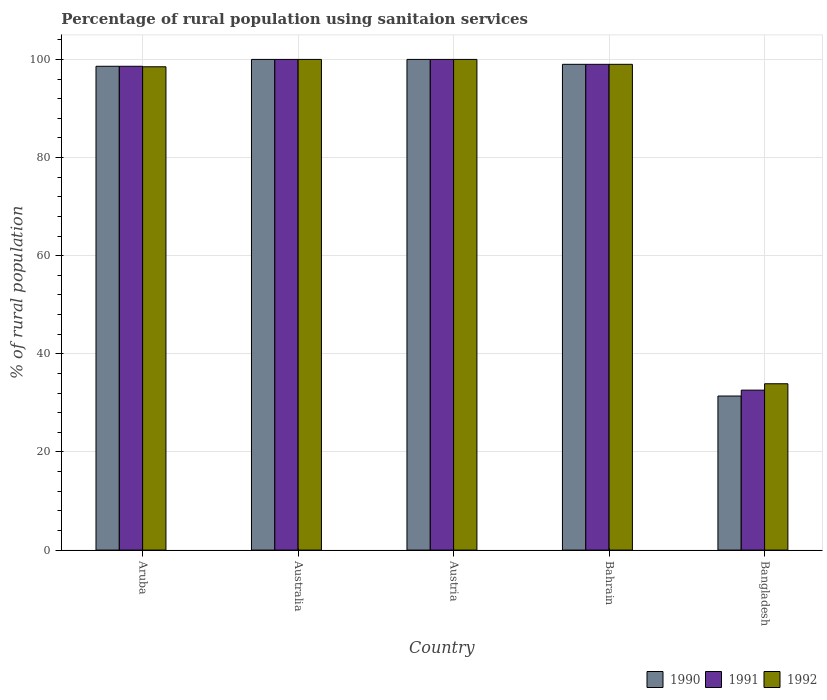How many different coloured bars are there?
Offer a terse response. 3. How many groups of bars are there?
Keep it short and to the point. 5. How many bars are there on the 5th tick from the left?
Your answer should be compact. 3. How many bars are there on the 1st tick from the right?
Keep it short and to the point. 3. What is the label of the 1st group of bars from the left?
Keep it short and to the point. Aruba. In how many cases, is the number of bars for a given country not equal to the number of legend labels?
Provide a succinct answer. 0. Across all countries, what is the minimum percentage of rural population using sanitaion services in 1991?
Provide a short and direct response. 32.6. In which country was the percentage of rural population using sanitaion services in 1990 maximum?
Your response must be concise. Australia. In which country was the percentage of rural population using sanitaion services in 1992 minimum?
Give a very brief answer. Bangladesh. What is the total percentage of rural population using sanitaion services in 1992 in the graph?
Ensure brevity in your answer.  431.4. What is the difference between the percentage of rural population using sanitaion services in 1991 in Australia and that in Bahrain?
Your response must be concise. 1. What is the average percentage of rural population using sanitaion services in 1991 per country?
Make the answer very short. 86.04. In how many countries, is the percentage of rural population using sanitaion services in 1992 greater than 88 %?
Ensure brevity in your answer.  4. What is the ratio of the percentage of rural population using sanitaion services in 1991 in Aruba to that in Bangladesh?
Offer a terse response. 3.02. Is the difference between the percentage of rural population using sanitaion services in 1992 in Australia and Bahrain greater than the difference between the percentage of rural population using sanitaion services in 1990 in Australia and Bahrain?
Offer a very short reply. No. What is the difference between the highest and the lowest percentage of rural population using sanitaion services in 1992?
Offer a very short reply. 66.1. In how many countries, is the percentage of rural population using sanitaion services in 1990 greater than the average percentage of rural population using sanitaion services in 1990 taken over all countries?
Make the answer very short. 4. Is the sum of the percentage of rural population using sanitaion services in 1991 in Aruba and Australia greater than the maximum percentage of rural population using sanitaion services in 1992 across all countries?
Offer a terse response. Yes. What does the 1st bar from the left in Australia represents?
Your response must be concise. 1990. Are all the bars in the graph horizontal?
Make the answer very short. No. What is the difference between two consecutive major ticks on the Y-axis?
Your answer should be very brief. 20. Does the graph contain grids?
Make the answer very short. Yes. How many legend labels are there?
Give a very brief answer. 3. How are the legend labels stacked?
Your answer should be very brief. Horizontal. What is the title of the graph?
Make the answer very short. Percentage of rural population using sanitaion services. Does "2007" appear as one of the legend labels in the graph?
Your answer should be very brief. No. What is the label or title of the Y-axis?
Ensure brevity in your answer.  % of rural population. What is the % of rural population of 1990 in Aruba?
Your answer should be very brief. 98.6. What is the % of rural population of 1991 in Aruba?
Offer a very short reply. 98.6. What is the % of rural population of 1992 in Aruba?
Provide a succinct answer. 98.5. What is the % of rural population in 1992 in Australia?
Your answer should be very brief. 100. What is the % of rural population of 1992 in Austria?
Your answer should be very brief. 100. What is the % of rural population of 1992 in Bahrain?
Your answer should be compact. 99. What is the % of rural population in 1990 in Bangladesh?
Give a very brief answer. 31.4. What is the % of rural population of 1991 in Bangladesh?
Your response must be concise. 32.6. What is the % of rural population of 1992 in Bangladesh?
Ensure brevity in your answer.  33.9. Across all countries, what is the maximum % of rural population in 1991?
Give a very brief answer. 100. Across all countries, what is the minimum % of rural population in 1990?
Give a very brief answer. 31.4. Across all countries, what is the minimum % of rural population in 1991?
Provide a succinct answer. 32.6. Across all countries, what is the minimum % of rural population of 1992?
Provide a short and direct response. 33.9. What is the total % of rural population of 1990 in the graph?
Your answer should be compact. 429. What is the total % of rural population of 1991 in the graph?
Offer a very short reply. 430.2. What is the total % of rural population in 1992 in the graph?
Provide a succinct answer. 431.4. What is the difference between the % of rural population of 1991 in Aruba and that in Australia?
Your response must be concise. -1.4. What is the difference between the % of rural population in 1992 in Aruba and that in Australia?
Offer a terse response. -1.5. What is the difference between the % of rural population in 1990 in Aruba and that in Austria?
Give a very brief answer. -1.4. What is the difference between the % of rural population of 1990 in Aruba and that in Bahrain?
Make the answer very short. -0.4. What is the difference between the % of rural population in 1991 in Aruba and that in Bahrain?
Offer a terse response. -0.4. What is the difference between the % of rural population in 1990 in Aruba and that in Bangladesh?
Offer a terse response. 67.2. What is the difference between the % of rural population in 1992 in Aruba and that in Bangladesh?
Ensure brevity in your answer.  64.6. What is the difference between the % of rural population in 1990 in Australia and that in Austria?
Your answer should be compact. 0. What is the difference between the % of rural population of 1992 in Australia and that in Austria?
Your answer should be very brief. 0. What is the difference between the % of rural population in 1991 in Australia and that in Bahrain?
Ensure brevity in your answer.  1. What is the difference between the % of rural population in 1992 in Australia and that in Bahrain?
Make the answer very short. 1. What is the difference between the % of rural population of 1990 in Australia and that in Bangladesh?
Make the answer very short. 68.6. What is the difference between the % of rural population of 1991 in Australia and that in Bangladesh?
Provide a short and direct response. 67.4. What is the difference between the % of rural population in 1992 in Australia and that in Bangladesh?
Make the answer very short. 66.1. What is the difference between the % of rural population in 1992 in Austria and that in Bahrain?
Provide a succinct answer. 1. What is the difference between the % of rural population in 1990 in Austria and that in Bangladesh?
Your answer should be compact. 68.6. What is the difference between the % of rural population in 1991 in Austria and that in Bangladesh?
Make the answer very short. 67.4. What is the difference between the % of rural population in 1992 in Austria and that in Bangladesh?
Your response must be concise. 66.1. What is the difference between the % of rural population of 1990 in Bahrain and that in Bangladesh?
Your response must be concise. 67.6. What is the difference between the % of rural population in 1991 in Bahrain and that in Bangladesh?
Provide a succinct answer. 66.4. What is the difference between the % of rural population of 1992 in Bahrain and that in Bangladesh?
Your response must be concise. 65.1. What is the difference between the % of rural population in 1990 in Aruba and the % of rural population in 1992 in Australia?
Your answer should be very brief. -1.4. What is the difference between the % of rural population of 1990 in Aruba and the % of rural population of 1991 in Austria?
Your answer should be very brief. -1.4. What is the difference between the % of rural population of 1990 in Aruba and the % of rural population of 1992 in Austria?
Offer a terse response. -1.4. What is the difference between the % of rural population of 1990 in Aruba and the % of rural population of 1992 in Bahrain?
Keep it short and to the point. -0.4. What is the difference between the % of rural population of 1990 in Aruba and the % of rural population of 1992 in Bangladesh?
Offer a very short reply. 64.7. What is the difference between the % of rural population of 1991 in Aruba and the % of rural population of 1992 in Bangladesh?
Ensure brevity in your answer.  64.7. What is the difference between the % of rural population in 1990 in Australia and the % of rural population in 1992 in Bahrain?
Your answer should be compact. 1. What is the difference between the % of rural population in 1990 in Australia and the % of rural population in 1991 in Bangladesh?
Your answer should be very brief. 67.4. What is the difference between the % of rural population in 1990 in Australia and the % of rural population in 1992 in Bangladesh?
Provide a succinct answer. 66.1. What is the difference between the % of rural population in 1991 in Australia and the % of rural population in 1992 in Bangladesh?
Your answer should be compact. 66.1. What is the difference between the % of rural population in 1990 in Austria and the % of rural population in 1992 in Bahrain?
Make the answer very short. 1. What is the difference between the % of rural population of 1990 in Austria and the % of rural population of 1991 in Bangladesh?
Provide a succinct answer. 67.4. What is the difference between the % of rural population of 1990 in Austria and the % of rural population of 1992 in Bangladesh?
Offer a terse response. 66.1. What is the difference between the % of rural population of 1991 in Austria and the % of rural population of 1992 in Bangladesh?
Make the answer very short. 66.1. What is the difference between the % of rural population in 1990 in Bahrain and the % of rural population in 1991 in Bangladesh?
Your answer should be very brief. 66.4. What is the difference between the % of rural population of 1990 in Bahrain and the % of rural population of 1992 in Bangladesh?
Your answer should be compact. 65.1. What is the difference between the % of rural population in 1991 in Bahrain and the % of rural population in 1992 in Bangladesh?
Your answer should be very brief. 65.1. What is the average % of rural population of 1990 per country?
Offer a terse response. 85.8. What is the average % of rural population in 1991 per country?
Your answer should be very brief. 86.04. What is the average % of rural population in 1992 per country?
Provide a short and direct response. 86.28. What is the difference between the % of rural population of 1990 and % of rural population of 1991 in Australia?
Keep it short and to the point. 0. What is the difference between the % of rural population in 1990 and % of rural population in 1992 in Australia?
Give a very brief answer. 0. What is the difference between the % of rural population of 1991 and % of rural population of 1992 in Australia?
Offer a terse response. 0. What is the difference between the % of rural population of 1990 and % of rural population of 1992 in Austria?
Offer a terse response. 0. What is the difference between the % of rural population of 1991 and % of rural population of 1992 in Austria?
Your answer should be very brief. 0. What is the difference between the % of rural population in 1990 and % of rural population in 1991 in Bahrain?
Provide a succinct answer. 0. What is the difference between the % of rural population in 1991 and % of rural population in 1992 in Bahrain?
Make the answer very short. 0. What is the difference between the % of rural population of 1991 and % of rural population of 1992 in Bangladesh?
Ensure brevity in your answer.  -1.3. What is the ratio of the % of rural population of 1991 in Aruba to that in Australia?
Provide a succinct answer. 0.99. What is the ratio of the % of rural population of 1992 in Aruba to that in Australia?
Give a very brief answer. 0.98. What is the ratio of the % of rural population of 1991 in Aruba to that in Austria?
Ensure brevity in your answer.  0.99. What is the ratio of the % of rural population in 1990 in Aruba to that in Bahrain?
Provide a short and direct response. 1. What is the ratio of the % of rural population of 1990 in Aruba to that in Bangladesh?
Offer a very short reply. 3.14. What is the ratio of the % of rural population of 1991 in Aruba to that in Bangladesh?
Your answer should be very brief. 3.02. What is the ratio of the % of rural population in 1992 in Aruba to that in Bangladesh?
Offer a very short reply. 2.91. What is the ratio of the % of rural population in 1990 in Australia to that in Austria?
Your response must be concise. 1. What is the ratio of the % of rural population in 1992 in Australia to that in Austria?
Your answer should be compact. 1. What is the ratio of the % of rural population in 1990 in Australia to that in Bahrain?
Keep it short and to the point. 1.01. What is the ratio of the % of rural population in 1992 in Australia to that in Bahrain?
Give a very brief answer. 1.01. What is the ratio of the % of rural population of 1990 in Australia to that in Bangladesh?
Your response must be concise. 3.18. What is the ratio of the % of rural population in 1991 in Australia to that in Bangladesh?
Keep it short and to the point. 3.07. What is the ratio of the % of rural population in 1992 in Australia to that in Bangladesh?
Ensure brevity in your answer.  2.95. What is the ratio of the % of rural population of 1990 in Austria to that in Bahrain?
Your answer should be very brief. 1.01. What is the ratio of the % of rural population of 1991 in Austria to that in Bahrain?
Your response must be concise. 1.01. What is the ratio of the % of rural population of 1990 in Austria to that in Bangladesh?
Keep it short and to the point. 3.18. What is the ratio of the % of rural population of 1991 in Austria to that in Bangladesh?
Your response must be concise. 3.07. What is the ratio of the % of rural population of 1992 in Austria to that in Bangladesh?
Give a very brief answer. 2.95. What is the ratio of the % of rural population in 1990 in Bahrain to that in Bangladesh?
Your answer should be very brief. 3.15. What is the ratio of the % of rural population in 1991 in Bahrain to that in Bangladesh?
Your answer should be compact. 3.04. What is the ratio of the % of rural population in 1992 in Bahrain to that in Bangladesh?
Provide a succinct answer. 2.92. What is the difference between the highest and the second highest % of rural population in 1990?
Provide a succinct answer. 0. What is the difference between the highest and the second highest % of rural population of 1991?
Provide a succinct answer. 0. What is the difference between the highest and the second highest % of rural population of 1992?
Keep it short and to the point. 0. What is the difference between the highest and the lowest % of rural population in 1990?
Keep it short and to the point. 68.6. What is the difference between the highest and the lowest % of rural population in 1991?
Give a very brief answer. 67.4. What is the difference between the highest and the lowest % of rural population in 1992?
Ensure brevity in your answer.  66.1. 